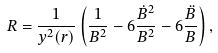<formula> <loc_0><loc_0><loc_500><loc_500>R = \frac { 1 } { y ^ { 2 } ( r ) } \left ( \frac { 1 } { B ^ { 2 } } - 6 \frac { \dot { B } ^ { 2 } } { B ^ { 2 } } - 6 \frac { \ddot { B } } { B } \right ) ,</formula> 